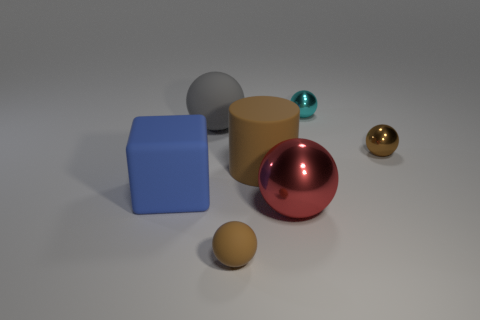Subtract all gray spheres. How many spheres are left? 4 Subtract all cyan balls. How many balls are left? 4 Subtract all blue balls. Subtract all yellow cylinders. How many balls are left? 5 Add 3 tiny cyan objects. How many objects exist? 10 Subtract all cylinders. How many objects are left? 6 Subtract all big brown cylinders. Subtract all brown balls. How many objects are left? 4 Add 6 blue blocks. How many blue blocks are left? 7 Add 3 small yellow balls. How many small yellow balls exist? 3 Subtract 0 yellow cylinders. How many objects are left? 7 